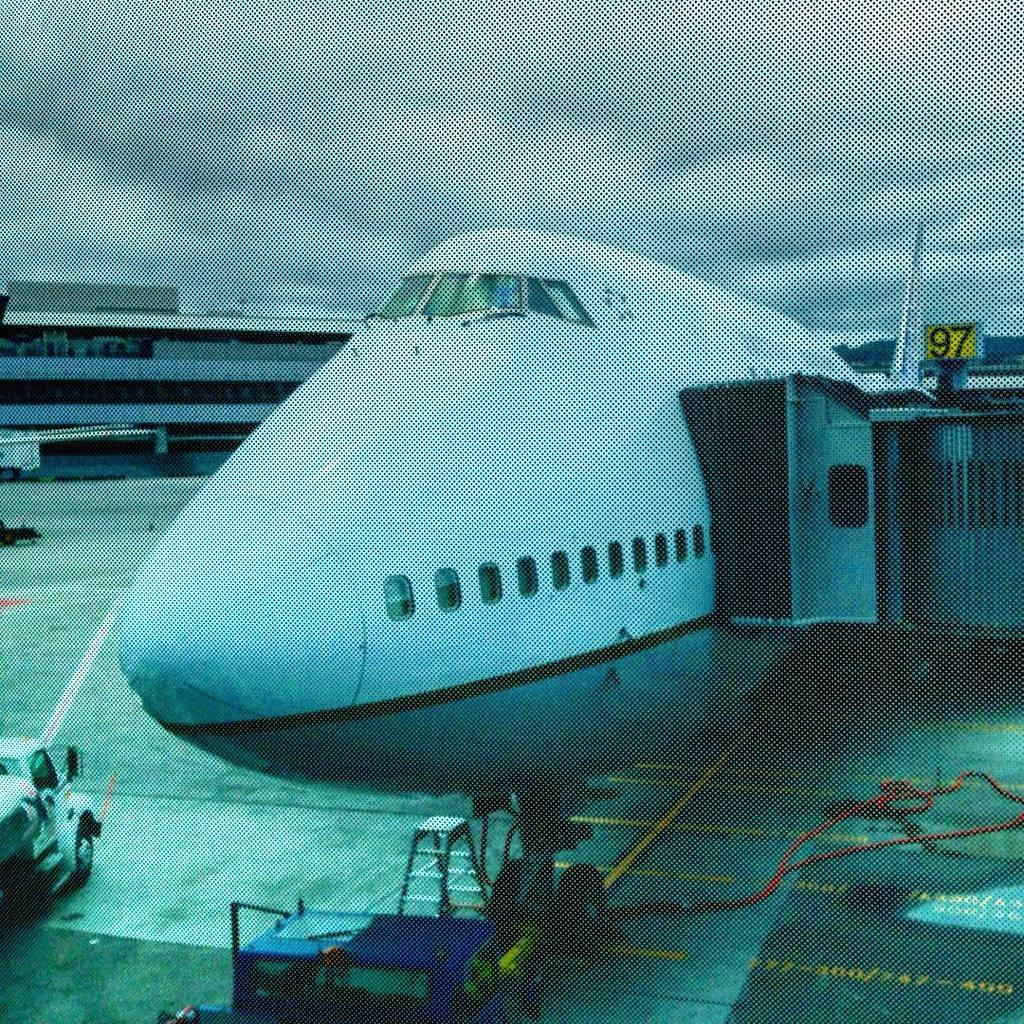<image>
Present a compact description of the photo's key features. A dark and grainy photo of a large jumbo jet parked at gate 97 at an airport. 